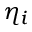Convert formula to latex. <formula><loc_0><loc_0><loc_500><loc_500>\eta _ { i }</formula> 